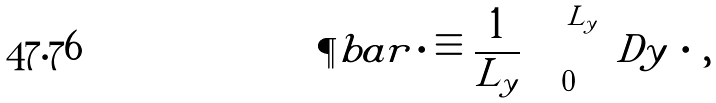<formula> <loc_0><loc_0><loc_500><loc_500>\P b a r \, \cdot \equiv \frac { 1 } { L _ { y } } \int _ { 0 } ^ { L _ { y } } \ D y \, \cdot \, ,</formula> 